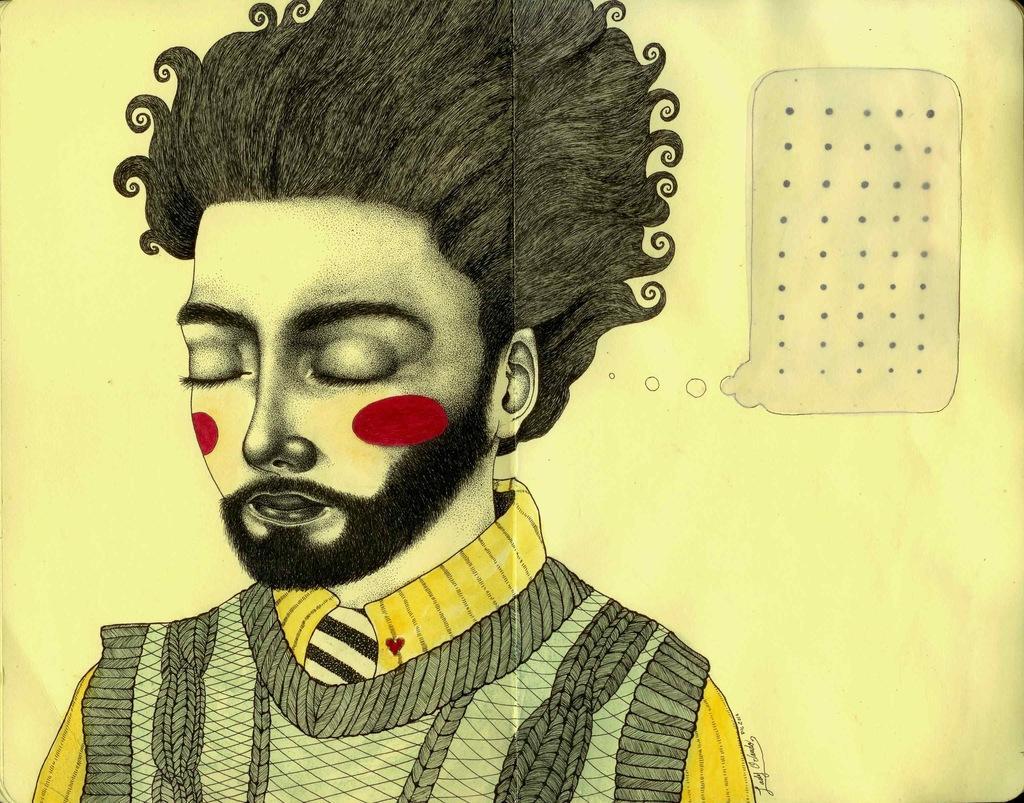How would you summarize this image in a sentence or two? This is an edited image in which there is a person in the foreground, in the background there might be the wall, on the wall there is an object visible. 